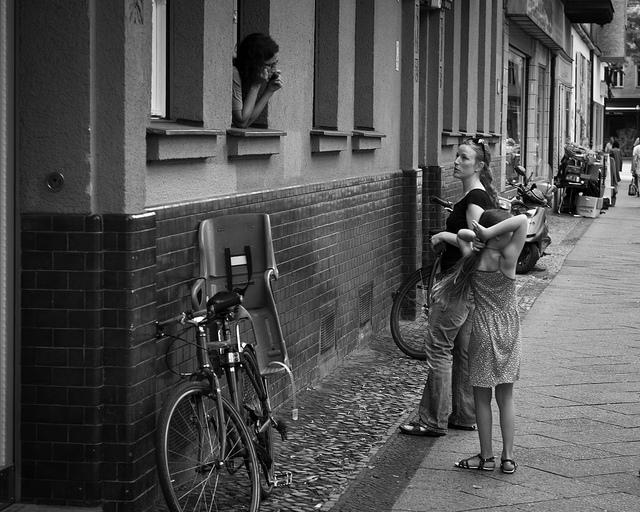What kind of bottoms is the woman in the foreground wearing?
Concise answer only. Pants. Are all three people the same age?
Quick response, please. No. What is the primary mode of transportation in this scene?
Answer briefly. Bike. Are the people crossing the street?
Concise answer only. No. Are they arguing with each other?
Keep it brief. No. Is the kickstand deployed?
Be succinct. No. 